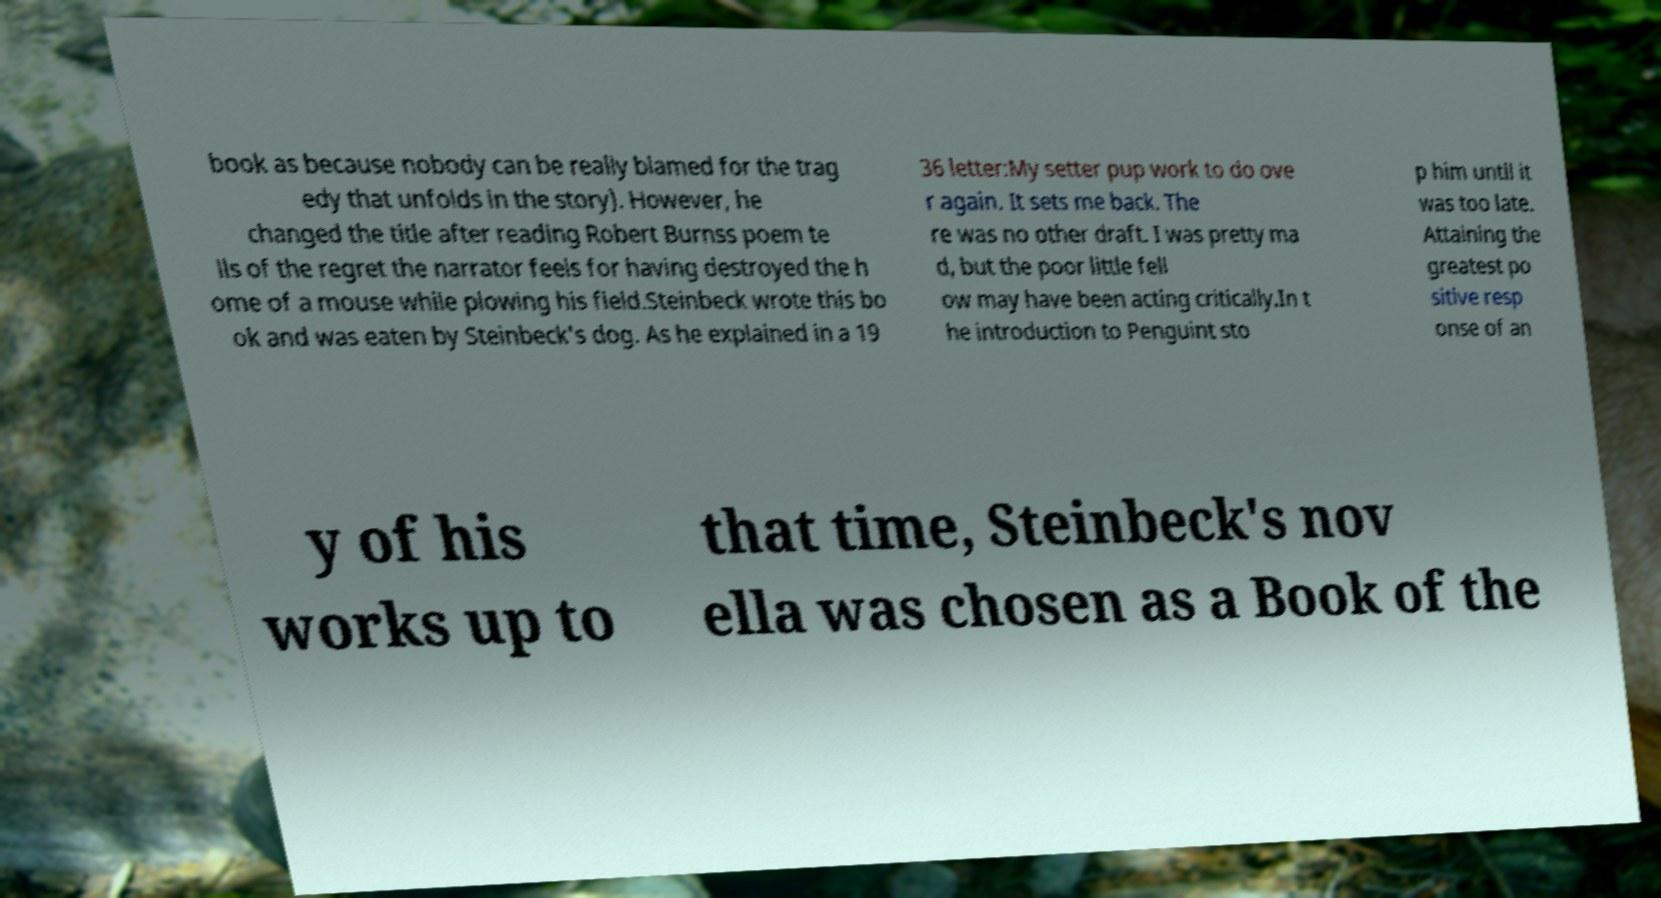Please read and relay the text visible in this image. What does it say? book as because nobody can be really blamed for the trag edy that unfolds in the story). However, he changed the title after reading Robert Burnss poem te lls of the regret the narrator feels for having destroyed the h ome of a mouse while plowing his field.Steinbeck wrote this bo ok and was eaten by Steinbeck's dog. As he explained in a 19 36 letter:My setter pup work to do ove r again. It sets me back. The re was no other draft. I was pretty ma d, but the poor little fell ow may have been acting critically.In t he introduction to Penguint sto p him until it was too late. Attaining the greatest po sitive resp onse of an y of his works up to that time, Steinbeck's nov ella was chosen as a Book of the 